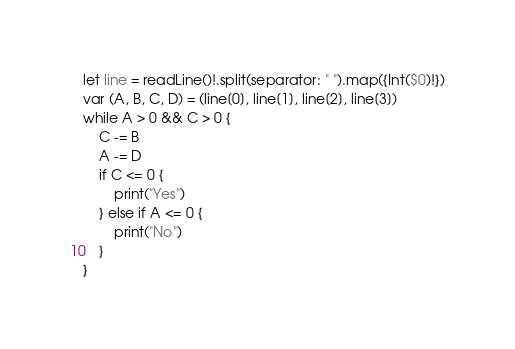Convert code to text. <code><loc_0><loc_0><loc_500><loc_500><_Swift_>let line = readLine()!.split(separator: " ").map({Int($0)!})
var (A, B, C, D) = (line[0], line[1], line[2], line[3])
while A > 0 && C > 0 {
    C -= B
    A -= D
    if C <= 0 {
        print("Yes")
    } else if A <= 0 {
        print("No")
    }
}
</code> 